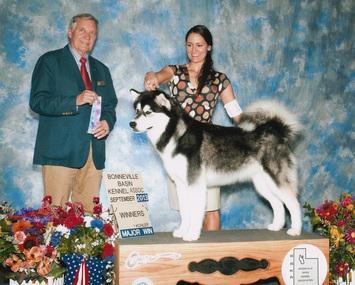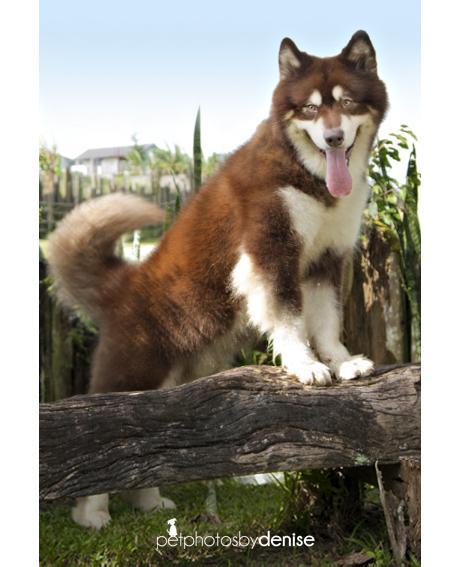The first image is the image on the left, the second image is the image on the right. Assess this claim about the two images: "Three people are sitting and posing for a portrait with a Malamute.". Correct or not? Answer yes or no. No. The first image is the image on the left, the second image is the image on the right. For the images displayed, is the sentence "The left image features at least two people and at least one open-mouthed dog, and they are posed with three of their heads in a row." factually correct? Answer yes or no. No. 